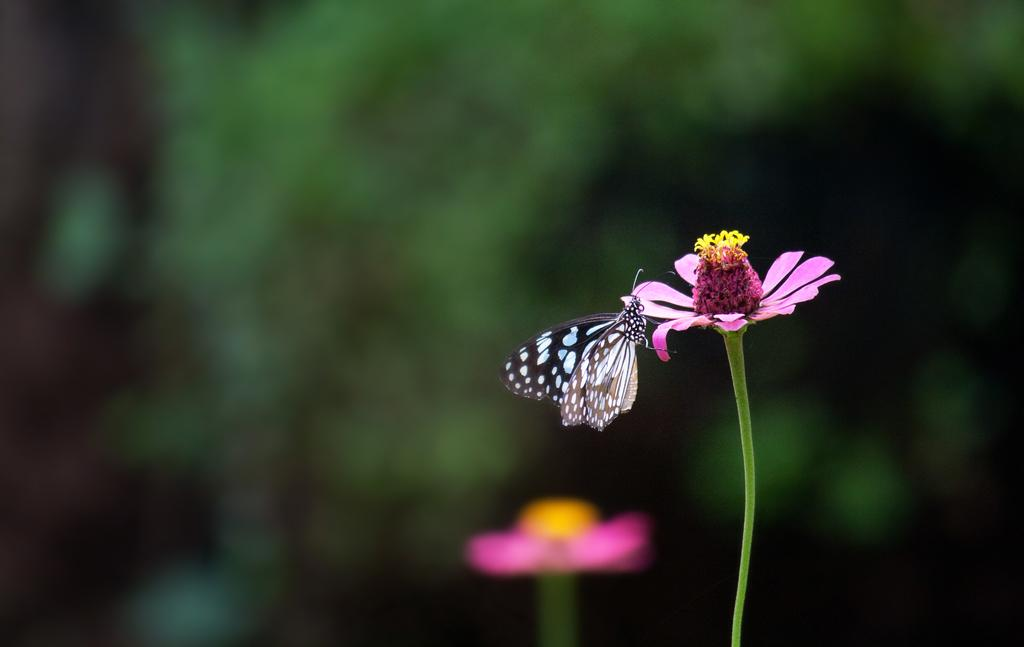What type of flower is in the image? There is a pink flower in the image. What other living creature can be seen in the image? There is a butterfly in the image. What color is present in the background of the image? The background of the image includes a pink color thing. How would you describe the focus of the image? The background of the image is blurry. What type of vegetable is being advertised in the image? There is no vegetable being advertised in the image; it features a pink flower and a butterfly. What show is being promoted in the image? There is no show being promoted in the image; it is a nature scene with a flower and a butterfly. 